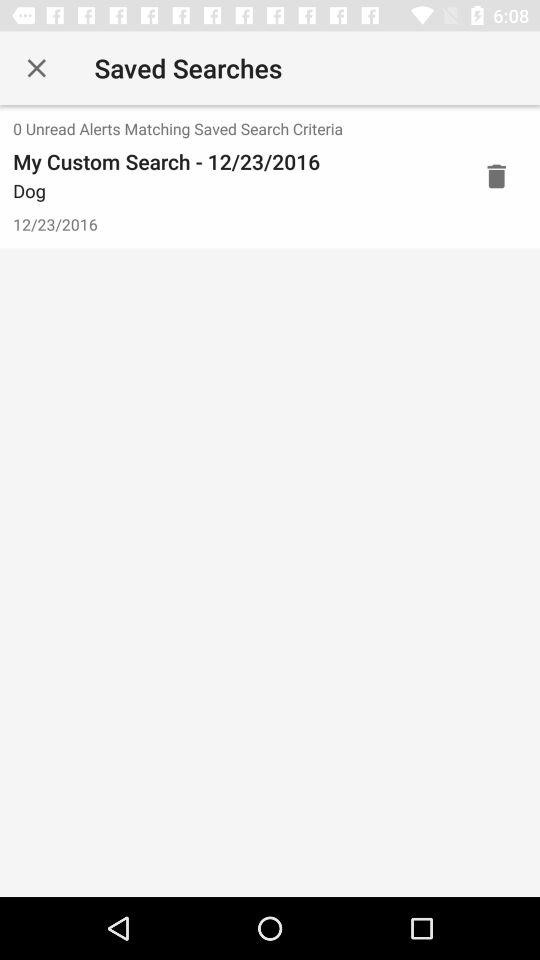How many "Unread Alerts Matching Saved Search Criteria" are there? There are 0 "Unread Alerts Matching Saved Search Criteria". 